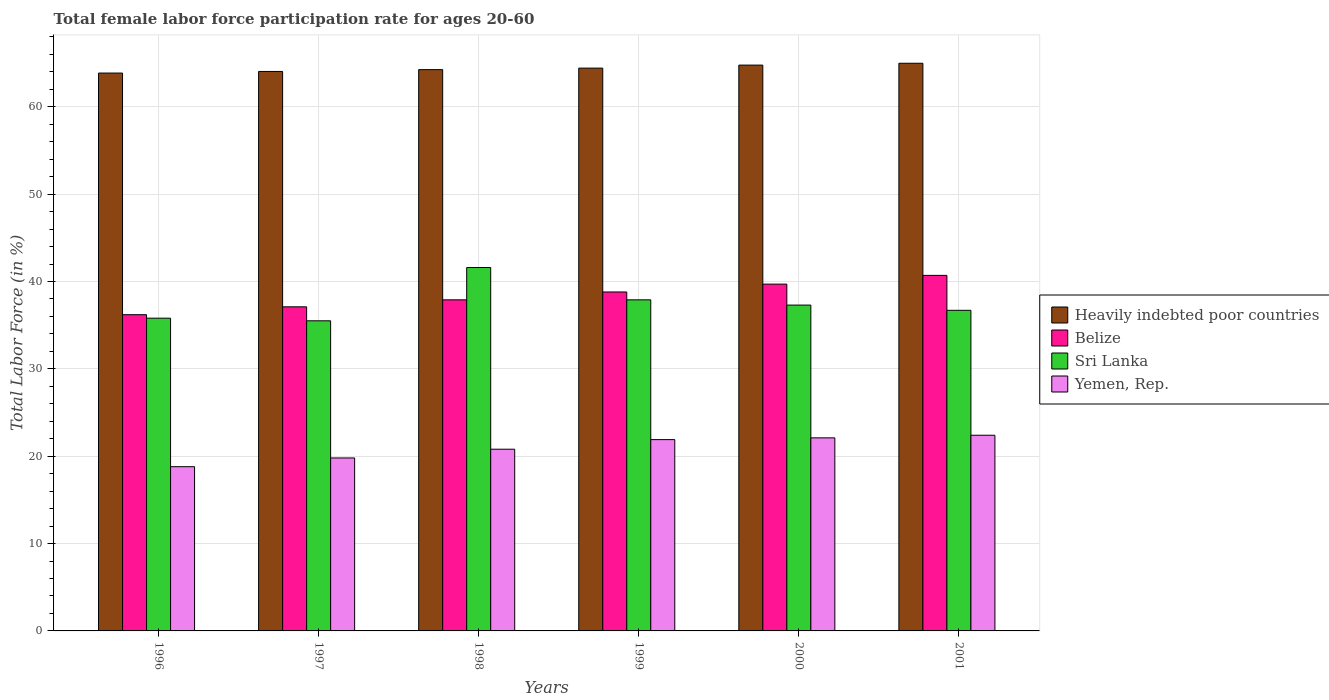How many different coloured bars are there?
Your answer should be very brief. 4. Are the number of bars per tick equal to the number of legend labels?
Your answer should be very brief. Yes. How many bars are there on the 5th tick from the right?
Offer a very short reply. 4. In how many cases, is the number of bars for a given year not equal to the number of legend labels?
Give a very brief answer. 0. What is the female labor force participation rate in Belize in 1999?
Provide a succinct answer. 38.8. Across all years, what is the maximum female labor force participation rate in Heavily indebted poor countries?
Offer a terse response. 64.98. Across all years, what is the minimum female labor force participation rate in Belize?
Your answer should be very brief. 36.2. In which year was the female labor force participation rate in Sri Lanka maximum?
Your answer should be compact. 1998. In which year was the female labor force participation rate in Sri Lanka minimum?
Ensure brevity in your answer.  1997. What is the total female labor force participation rate in Yemen, Rep. in the graph?
Offer a very short reply. 125.8. What is the difference between the female labor force participation rate in Belize in 1999 and that in 2000?
Offer a terse response. -0.9. What is the average female labor force participation rate in Heavily indebted poor countries per year?
Ensure brevity in your answer.  64.39. In the year 2001, what is the difference between the female labor force participation rate in Yemen, Rep. and female labor force participation rate in Sri Lanka?
Give a very brief answer. -14.3. In how many years, is the female labor force participation rate in Heavily indebted poor countries greater than 36 %?
Offer a terse response. 6. What is the ratio of the female labor force participation rate in Sri Lanka in 1997 to that in 1998?
Your answer should be compact. 0.85. Is the difference between the female labor force participation rate in Yemen, Rep. in 1996 and 1998 greater than the difference between the female labor force participation rate in Sri Lanka in 1996 and 1998?
Your response must be concise. Yes. What is the difference between the highest and the second highest female labor force participation rate in Belize?
Give a very brief answer. 1. What is the difference between the highest and the lowest female labor force participation rate in Heavily indebted poor countries?
Make the answer very short. 1.12. Is it the case that in every year, the sum of the female labor force participation rate in Yemen, Rep. and female labor force participation rate in Belize is greater than the sum of female labor force participation rate in Sri Lanka and female labor force participation rate in Heavily indebted poor countries?
Offer a very short reply. No. What does the 1st bar from the left in 2001 represents?
Give a very brief answer. Heavily indebted poor countries. What does the 3rd bar from the right in 1997 represents?
Your answer should be very brief. Belize. Is it the case that in every year, the sum of the female labor force participation rate in Sri Lanka and female labor force participation rate in Yemen, Rep. is greater than the female labor force participation rate in Belize?
Give a very brief answer. Yes. Are all the bars in the graph horizontal?
Provide a short and direct response. No. What is the difference between two consecutive major ticks on the Y-axis?
Ensure brevity in your answer.  10. Are the values on the major ticks of Y-axis written in scientific E-notation?
Make the answer very short. No. Does the graph contain any zero values?
Keep it short and to the point. No. Where does the legend appear in the graph?
Make the answer very short. Center right. How many legend labels are there?
Your answer should be very brief. 4. How are the legend labels stacked?
Offer a very short reply. Vertical. What is the title of the graph?
Give a very brief answer. Total female labor force participation rate for ages 20-60. Does "Guatemala" appear as one of the legend labels in the graph?
Make the answer very short. No. What is the Total Labor Force (in %) of Heavily indebted poor countries in 1996?
Provide a short and direct response. 63.86. What is the Total Labor Force (in %) in Belize in 1996?
Make the answer very short. 36.2. What is the Total Labor Force (in %) of Sri Lanka in 1996?
Ensure brevity in your answer.  35.8. What is the Total Labor Force (in %) of Yemen, Rep. in 1996?
Offer a very short reply. 18.8. What is the Total Labor Force (in %) of Heavily indebted poor countries in 1997?
Your answer should be very brief. 64.04. What is the Total Labor Force (in %) in Belize in 1997?
Ensure brevity in your answer.  37.1. What is the Total Labor Force (in %) in Sri Lanka in 1997?
Ensure brevity in your answer.  35.5. What is the Total Labor Force (in %) in Yemen, Rep. in 1997?
Ensure brevity in your answer.  19.8. What is the Total Labor Force (in %) of Heavily indebted poor countries in 1998?
Ensure brevity in your answer.  64.25. What is the Total Labor Force (in %) of Belize in 1998?
Ensure brevity in your answer.  37.9. What is the Total Labor Force (in %) of Sri Lanka in 1998?
Provide a short and direct response. 41.6. What is the Total Labor Force (in %) of Yemen, Rep. in 1998?
Your response must be concise. 20.8. What is the Total Labor Force (in %) of Heavily indebted poor countries in 1999?
Provide a succinct answer. 64.43. What is the Total Labor Force (in %) in Belize in 1999?
Your answer should be very brief. 38.8. What is the Total Labor Force (in %) of Sri Lanka in 1999?
Provide a succinct answer. 37.9. What is the Total Labor Force (in %) in Yemen, Rep. in 1999?
Keep it short and to the point. 21.9. What is the Total Labor Force (in %) in Heavily indebted poor countries in 2000?
Give a very brief answer. 64.77. What is the Total Labor Force (in %) in Belize in 2000?
Keep it short and to the point. 39.7. What is the Total Labor Force (in %) of Sri Lanka in 2000?
Offer a very short reply. 37.3. What is the Total Labor Force (in %) of Yemen, Rep. in 2000?
Your answer should be compact. 22.1. What is the Total Labor Force (in %) of Heavily indebted poor countries in 2001?
Give a very brief answer. 64.98. What is the Total Labor Force (in %) in Belize in 2001?
Your response must be concise. 40.7. What is the Total Labor Force (in %) of Sri Lanka in 2001?
Keep it short and to the point. 36.7. What is the Total Labor Force (in %) in Yemen, Rep. in 2001?
Keep it short and to the point. 22.4. Across all years, what is the maximum Total Labor Force (in %) in Heavily indebted poor countries?
Provide a succinct answer. 64.98. Across all years, what is the maximum Total Labor Force (in %) of Belize?
Provide a succinct answer. 40.7. Across all years, what is the maximum Total Labor Force (in %) in Sri Lanka?
Give a very brief answer. 41.6. Across all years, what is the maximum Total Labor Force (in %) of Yemen, Rep.?
Make the answer very short. 22.4. Across all years, what is the minimum Total Labor Force (in %) of Heavily indebted poor countries?
Your answer should be very brief. 63.86. Across all years, what is the minimum Total Labor Force (in %) of Belize?
Keep it short and to the point. 36.2. Across all years, what is the minimum Total Labor Force (in %) in Sri Lanka?
Give a very brief answer. 35.5. Across all years, what is the minimum Total Labor Force (in %) in Yemen, Rep.?
Your answer should be compact. 18.8. What is the total Total Labor Force (in %) of Heavily indebted poor countries in the graph?
Keep it short and to the point. 386.34. What is the total Total Labor Force (in %) in Belize in the graph?
Your response must be concise. 230.4. What is the total Total Labor Force (in %) in Sri Lanka in the graph?
Ensure brevity in your answer.  224.8. What is the total Total Labor Force (in %) of Yemen, Rep. in the graph?
Your answer should be very brief. 125.8. What is the difference between the Total Labor Force (in %) in Heavily indebted poor countries in 1996 and that in 1997?
Make the answer very short. -0.18. What is the difference between the Total Labor Force (in %) of Belize in 1996 and that in 1997?
Provide a succinct answer. -0.9. What is the difference between the Total Labor Force (in %) in Heavily indebted poor countries in 1996 and that in 1998?
Give a very brief answer. -0.39. What is the difference between the Total Labor Force (in %) in Sri Lanka in 1996 and that in 1998?
Offer a terse response. -5.8. What is the difference between the Total Labor Force (in %) in Heavily indebted poor countries in 1996 and that in 1999?
Provide a short and direct response. -0.57. What is the difference between the Total Labor Force (in %) in Heavily indebted poor countries in 1996 and that in 2000?
Offer a terse response. -0.91. What is the difference between the Total Labor Force (in %) of Belize in 1996 and that in 2000?
Your answer should be very brief. -3.5. What is the difference between the Total Labor Force (in %) of Sri Lanka in 1996 and that in 2000?
Keep it short and to the point. -1.5. What is the difference between the Total Labor Force (in %) in Yemen, Rep. in 1996 and that in 2000?
Offer a very short reply. -3.3. What is the difference between the Total Labor Force (in %) in Heavily indebted poor countries in 1996 and that in 2001?
Offer a very short reply. -1.12. What is the difference between the Total Labor Force (in %) in Belize in 1996 and that in 2001?
Offer a very short reply. -4.5. What is the difference between the Total Labor Force (in %) of Heavily indebted poor countries in 1997 and that in 1998?
Offer a very short reply. -0.21. What is the difference between the Total Labor Force (in %) of Heavily indebted poor countries in 1997 and that in 1999?
Offer a very short reply. -0.38. What is the difference between the Total Labor Force (in %) of Heavily indebted poor countries in 1997 and that in 2000?
Your response must be concise. -0.73. What is the difference between the Total Labor Force (in %) of Sri Lanka in 1997 and that in 2000?
Provide a short and direct response. -1.8. What is the difference between the Total Labor Force (in %) in Yemen, Rep. in 1997 and that in 2000?
Give a very brief answer. -2.3. What is the difference between the Total Labor Force (in %) in Heavily indebted poor countries in 1997 and that in 2001?
Offer a very short reply. -0.94. What is the difference between the Total Labor Force (in %) of Belize in 1997 and that in 2001?
Your answer should be very brief. -3.6. What is the difference between the Total Labor Force (in %) in Sri Lanka in 1997 and that in 2001?
Your answer should be compact. -1.2. What is the difference between the Total Labor Force (in %) of Heavily indebted poor countries in 1998 and that in 1999?
Your answer should be compact. -0.17. What is the difference between the Total Labor Force (in %) in Yemen, Rep. in 1998 and that in 1999?
Provide a succinct answer. -1.1. What is the difference between the Total Labor Force (in %) in Heavily indebted poor countries in 1998 and that in 2000?
Provide a succinct answer. -0.52. What is the difference between the Total Labor Force (in %) of Sri Lanka in 1998 and that in 2000?
Your answer should be compact. 4.3. What is the difference between the Total Labor Force (in %) in Heavily indebted poor countries in 1998 and that in 2001?
Your answer should be very brief. -0.73. What is the difference between the Total Labor Force (in %) of Sri Lanka in 1998 and that in 2001?
Provide a short and direct response. 4.9. What is the difference between the Total Labor Force (in %) of Heavily indebted poor countries in 1999 and that in 2000?
Give a very brief answer. -0.35. What is the difference between the Total Labor Force (in %) of Belize in 1999 and that in 2000?
Provide a short and direct response. -0.9. What is the difference between the Total Labor Force (in %) in Heavily indebted poor countries in 1999 and that in 2001?
Keep it short and to the point. -0.56. What is the difference between the Total Labor Force (in %) of Sri Lanka in 1999 and that in 2001?
Provide a short and direct response. 1.2. What is the difference between the Total Labor Force (in %) in Yemen, Rep. in 1999 and that in 2001?
Ensure brevity in your answer.  -0.5. What is the difference between the Total Labor Force (in %) of Heavily indebted poor countries in 2000 and that in 2001?
Provide a short and direct response. -0.21. What is the difference between the Total Labor Force (in %) in Sri Lanka in 2000 and that in 2001?
Ensure brevity in your answer.  0.6. What is the difference between the Total Labor Force (in %) of Heavily indebted poor countries in 1996 and the Total Labor Force (in %) of Belize in 1997?
Provide a succinct answer. 26.76. What is the difference between the Total Labor Force (in %) of Heavily indebted poor countries in 1996 and the Total Labor Force (in %) of Sri Lanka in 1997?
Offer a very short reply. 28.36. What is the difference between the Total Labor Force (in %) of Heavily indebted poor countries in 1996 and the Total Labor Force (in %) of Yemen, Rep. in 1997?
Ensure brevity in your answer.  44.06. What is the difference between the Total Labor Force (in %) of Heavily indebted poor countries in 1996 and the Total Labor Force (in %) of Belize in 1998?
Provide a short and direct response. 25.96. What is the difference between the Total Labor Force (in %) of Heavily indebted poor countries in 1996 and the Total Labor Force (in %) of Sri Lanka in 1998?
Give a very brief answer. 22.26. What is the difference between the Total Labor Force (in %) in Heavily indebted poor countries in 1996 and the Total Labor Force (in %) in Yemen, Rep. in 1998?
Offer a very short reply. 43.06. What is the difference between the Total Labor Force (in %) in Belize in 1996 and the Total Labor Force (in %) in Sri Lanka in 1998?
Offer a very short reply. -5.4. What is the difference between the Total Labor Force (in %) of Heavily indebted poor countries in 1996 and the Total Labor Force (in %) of Belize in 1999?
Provide a succinct answer. 25.06. What is the difference between the Total Labor Force (in %) in Heavily indebted poor countries in 1996 and the Total Labor Force (in %) in Sri Lanka in 1999?
Offer a very short reply. 25.96. What is the difference between the Total Labor Force (in %) in Heavily indebted poor countries in 1996 and the Total Labor Force (in %) in Yemen, Rep. in 1999?
Your answer should be very brief. 41.96. What is the difference between the Total Labor Force (in %) of Sri Lanka in 1996 and the Total Labor Force (in %) of Yemen, Rep. in 1999?
Your answer should be compact. 13.9. What is the difference between the Total Labor Force (in %) in Heavily indebted poor countries in 1996 and the Total Labor Force (in %) in Belize in 2000?
Provide a succinct answer. 24.16. What is the difference between the Total Labor Force (in %) of Heavily indebted poor countries in 1996 and the Total Labor Force (in %) of Sri Lanka in 2000?
Make the answer very short. 26.56. What is the difference between the Total Labor Force (in %) of Heavily indebted poor countries in 1996 and the Total Labor Force (in %) of Yemen, Rep. in 2000?
Offer a terse response. 41.76. What is the difference between the Total Labor Force (in %) in Belize in 1996 and the Total Labor Force (in %) in Sri Lanka in 2000?
Ensure brevity in your answer.  -1.1. What is the difference between the Total Labor Force (in %) of Heavily indebted poor countries in 1996 and the Total Labor Force (in %) of Belize in 2001?
Your answer should be compact. 23.16. What is the difference between the Total Labor Force (in %) in Heavily indebted poor countries in 1996 and the Total Labor Force (in %) in Sri Lanka in 2001?
Your response must be concise. 27.16. What is the difference between the Total Labor Force (in %) in Heavily indebted poor countries in 1996 and the Total Labor Force (in %) in Yemen, Rep. in 2001?
Provide a succinct answer. 41.46. What is the difference between the Total Labor Force (in %) of Belize in 1996 and the Total Labor Force (in %) of Yemen, Rep. in 2001?
Offer a very short reply. 13.8. What is the difference between the Total Labor Force (in %) of Heavily indebted poor countries in 1997 and the Total Labor Force (in %) of Belize in 1998?
Your answer should be compact. 26.14. What is the difference between the Total Labor Force (in %) in Heavily indebted poor countries in 1997 and the Total Labor Force (in %) in Sri Lanka in 1998?
Keep it short and to the point. 22.44. What is the difference between the Total Labor Force (in %) of Heavily indebted poor countries in 1997 and the Total Labor Force (in %) of Yemen, Rep. in 1998?
Provide a short and direct response. 43.24. What is the difference between the Total Labor Force (in %) of Belize in 1997 and the Total Labor Force (in %) of Yemen, Rep. in 1998?
Give a very brief answer. 16.3. What is the difference between the Total Labor Force (in %) of Heavily indebted poor countries in 1997 and the Total Labor Force (in %) of Belize in 1999?
Provide a short and direct response. 25.24. What is the difference between the Total Labor Force (in %) in Heavily indebted poor countries in 1997 and the Total Labor Force (in %) in Sri Lanka in 1999?
Your response must be concise. 26.14. What is the difference between the Total Labor Force (in %) of Heavily indebted poor countries in 1997 and the Total Labor Force (in %) of Yemen, Rep. in 1999?
Offer a very short reply. 42.14. What is the difference between the Total Labor Force (in %) of Belize in 1997 and the Total Labor Force (in %) of Sri Lanka in 1999?
Give a very brief answer. -0.8. What is the difference between the Total Labor Force (in %) in Sri Lanka in 1997 and the Total Labor Force (in %) in Yemen, Rep. in 1999?
Keep it short and to the point. 13.6. What is the difference between the Total Labor Force (in %) in Heavily indebted poor countries in 1997 and the Total Labor Force (in %) in Belize in 2000?
Make the answer very short. 24.34. What is the difference between the Total Labor Force (in %) of Heavily indebted poor countries in 1997 and the Total Labor Force (in %) of Sri Lanka in 2000?
Make the answer very short. 26.74. What is the difference between the Total Labor Force (in %) of Heavily indebted poor countries in 1997 and the Total Labor Force (in %) of Yemen, Rep. in 2000?
Your answer should be compact. 41.94. What is the difference between the Total Labor Force (in %) in Belize in 1997 and the Total Labor Force (in %) in Sri Lanka in 2000?
Keep it short and to the point. -0.2. What is the difference between the Total Labor Force (in %) in Belize in 1997 and the Total Labor Force (in %) in Yemen, Rep. in 2000?
Offer a terse response. 15. What is the difference between the Total Labor Force (in %) of Heavily indebted poor countries in 1997 and the Total Labor Force (in %) of Belize in 2001?
Your answer should be compact. 23.34. What is the difference between the Total Labor Force (in %) of Heavily indebted poor countries in 1997 and the Total Labor Force (in %) of Sri Lanka in 2001?
Ensure brevity in your answer.  27.34. What is the difference between the Total Labor Force (in %) of Heavily indebted poor countries in 1997 and the Total Labor Force (in %) of Yemen, Rep. in 2001?
Provide a succinct answer. 41.64. What is the difference between the Total Labor Force (in %) in Belize in 1997 and the Total Labor Force (in %) in Sri Lanka in 2001?
Offer a terse response. 0.4. What is the difference between the Total Labor Force (in %) in Sri Lanka in 1997 and the Total Labor Force (in %) in Yemen, Rep. in 2001?
Offer a very short reply. 13.1. What is the difference between the Total Labor Force (in %) of Heavily indebted poor countries in 1998 and the Total Labor Force (in %) of Belize in 1999?
Your response must be concise. 25.45. What is the difference between the Total Labor Force (in %) in Heavily indebted poor countries in 1998 and the Total Labor Force (in %) in Sri Lanka in 1999?
Offer a very short reply. 26.35. What is the difference between the Total Labor Force (in %) in Heavily indebted poor countries in 1998 and the Total Labor Force (in %) in Yemen, Rep. in 1999?
Provide a short and direct response. 42.35. What is the difference between the Total Labor Force (in %) in Belize in 1998 and the Total Labor Force (in %) in Sri Lanka in 1999?
Your response must be concise. 0. What is the difference between the Total Labor Force (in %) of Sri Lanka in 1998 and the Total Labor Force (in %) of Yemen, Rep. in 1999?
Give a very brief answer. 19.7. What is the difference between the Total Labor Force (in %) in Heavily indebted poor countries in 1998 and the Total Labor Force (in %) in Belize in 2000?
Offer a terse response. 24.55. What is the difference between the Total Labor Force (in %) in Heavily indebted poor countries in 1998 and the Total Labor Force (in %) in Sri Lanka in 2000?
Offer a terse response. 26.95. What is the difference between the Total Labor Force (in %) in Heavily indebted poor countries in 1998 and the Total Labor Force (in %) in Yemen, Rep. in 2000?
Keep it short and to the point. 42.15. What is the difference between the Total Labor Force (in %) of Belize in 1998 and the Total Labor Force (in %) of Yemen, Rep. in 2000?
Give a very brief answer. 15.8. What is the difference between the Total Labor Force (in %) of Heavily indebted poor countries in 1998 and the Total Labor Force (in %) of Belize in 2001?
Your response must be concise. 23.55. What is the difference between the Total Labor Force (in %) in Heavily indebted poor countries in 1998 and the Total Labor Force (in %) in Sri Lanka in 2001?
Ensure brevity in your answer.  27.55. What is the difference between the Total Labor Force (in %) in Heavily indebted poor countries in 1998 and the Total Labor Force (in %) in Yemen, Rep. in 2001?
Offer a very short reply. 41.85. What is the difference between the Total Labor Force (in %) in Belize in 1998 and the Total Labor Force (in %) in Sri Lanka in 2001?
Offer a very short reply. 1.2. What is the difference between the Total Labor Force (in %) in Sri Lanka in 1998 and the Total Labor Force (in %) in Yemen, Rep. in 2001?
Provide a succinct answer. 19.2. What is the difference between the Total Labor Force (in %) of Heavily indebted poor countries in 1999 and the Total Labor Force (in %) of Belize in 2000?
Give a very brief answer. 24.73. What is the difference between the Total Labor Force (in %) of Heavily indebted poor countries in 1999 and the Total Labor Force (in %) of Sri Lanka in 2000?
Offer a very short reply. 27.13. What is the difference between the Total Labor Force (in %) in Heavily indebted poor countries in 1999 and the Total Labor Force (in %) in Yemen, Rep. in 2000?
Offer a very short reply. 42.33. What is the difference between the Total Labor Force (in %) of Belize in 1999 and the Total Labor Force (in %) of Sri Lanka in 2000?
Your answer should be very brief. 1.5. What is the difference between the Total Labor Force (in %) in Heavily indebted poor countries in 1999 and the Total Labor Force (in %) in Belize in 2001?
Your answer should be compact. 23.73. What is the difference between the Total Labor Force (in %) in Heavily indebted poor countries in 1999 and the Total Labor Force (in %) in Sri Lanka in 2001?
Your answer should be compact. 27.73. What is the difference between the Total Labor Force (in %) in Heavily indebted poor countries in 1999 and the Total Labor Force (in %) in Yemen, Rep. in 2001?
Your answer should be compact. 42.03. What is the difference between the Total Labor Force (in %) of Belize in 1999 and the Total Labor Force (in %) of Sri Lanka in 2001?
Your answer should be compact. 2.1. What is the difference between the Total Labor Force (in %) of Belize in 1999 and the Total Labor Force (in %) of Yemen, Rep. in 2001?
Ensure brevity in your answer.  16.4. What is the difference between the Total Labor Force (in %) of Heavily indebted poor countries in 2000 and the Total Labor Force (in %) of Belize in 2001?
Offer a terse response. 24.07. What is the difference between the Total Labor Force (in %) in Heavily indebted poor countries in 2000 and the Total Labor Force (in %) in Sri Lanka in 2001?
Provide a short and direct response. 28.07. What is the difference between the Total Labor Force (in %) in Heavily indebted poor countries in 2000 and the Total Labor Force (in %) in Yemen, Rep. in 2001?
Your answer should be very brief. 42.37. What is the difference between the Total Labor Force (in %) in Sri Lanka in 2000 and the Total Labor Force (in %) in Yemen, Rep. in 2001?
Offer a very short reply. 14.9. What is the average Total Labor Force (in %) of Heavily indebted poor countries per year?
Keep it short and to the point. 64.39. What is the average Total Labor Force (in %) of Belize per year?
Make the answer very short. 38.4. What is the average Total Labor Force (in %) of Sri Lanka per year?
Ensure brevity in your answer.  37.47. What is the average Total Labor Force (in %) in Yemen, Rep. per year?
Offer a very short reply. 20.97. In the year 1996, what is the difference between the Total Labor Force (in %) of Heavily indebted poor countries and Total Labor Force (in %) of Belize?
Ensure brevity in your answer.  27.66. In the year 1996, what is the difference between the Total Labor Force (in %) in Heavily indebted poor countries and Total Labor Force (in %) in Sri Lanka?
Keep it short and to the point. 28.06. In the year 1996, what is the difference between the Total Labor Force (in %) of Heavily indebted poor countries and Total Labor Force (in %) of Yemen, Rep.?
Offer a very short reply. 45.06. In the year 1996, what is the difference between the Total Labor Force (in %) in Belize and Total Labor Force (in %) in Sri Lanka?
Offer a very short reply. 0.4. In the year 1996, what is the difference between the Total Labor Force (in %) in Sri Lanka and Total Labor Force (in %) in Yemen, Rep.?
Keep it short and to the point. 17. In the year 1997, what is the difference between the Total Labor Force (in %) in Heavily indebted poor countries and Total Labor Force (in %) in Belize?
Keep it short and to the point. 26.94. In the year 1997, what is the difference between the Total Labor Force (in %) of Heavily indebted poor countries and Total Labor Force (in %) of Sri Lanka?
Offer a terse response. 28.54. In the year 1997, what is the difference between the Total Labor Force (in %) of Heavily indebted poor countries and Total Labor Force (in %) of Yemen, Rep.?
Give a very brief answer. 44.24. In the year 1997, what is the difference between the Total Labor Force (in %) of Belize and Total Labor Force (in %) of Sri Lanka?
Provide a short and direct response. 1.6. In the year 1997, what is the difference between the Total Labor Force (in %) of Sri Lanka and Total Labor Force (in %) of Yemen, Rep.?
Keep it short and to the point. 15.7. In the year 1998, what is the difference between the Total Labor Force (in %) in Heavily indebted poor countries and Total Labor Force (in %) in Belize?
Make the answer very short. 26.35. In the year 1998, what is the difference between the Total Labor Force (in %) in Heavily indebted poor countries and Total Labor Force (in %) in Sri Lanka?
Ensure brevity in your answer.  22.65. In the year 1998, what is the difference between the Total Labor Force (in %) of Heavily indebted poor countries and Total Labor Force (in %) of Yemen, Rep.?
Keep it short and to the point. 43.45. In the year 1998, what is the difference between the Total Labor Force (in %) of Belize and Total Labor Force (in %) of Yemen, Rep.?
Offer a terse response. 17.1. In the year 1998, what is the difference between the Total Labor Force (in %) of Sri Lanka and Total Labor Force (in %) of Yemen, Rep.?
Give a very brief answer. 20.8. In the year 1999, what is the difference between the Total Labor Force (in %) in Heavily indebted poor countries and Total Labor Force (in %) in Belize?
Provide a short and direct response. 25.63. In the year 1999, what is the difference between the Total Labor Force (in %) of Heavily indebted poor countries and Total Labor Force (in %) of Sri Lanka?
Your response must be concise. 26.53. In the year 1999, what is the difference between the Total Labor Force (in %) of Heavily indebted poor countries and Total Labor Force (in %) of Yemen, Rep.?
Give a very brief answer. 42.53. In the year 2000, what is the difference between the Total Labor Force (in %) in Heavily indebted poor countries and Total Labor Force (in %) in Belize?
Your answer should be very brief. 25.07. In the year 2000, what is the difference between the Total Labor Force (in %) in Heavily indebted poor countries and Total Labor Force (in %) in Sri Lanka?
Ensure brevity in your answer.  27.47. In the year 2000, what is the difference between the Total Labor Force (in %) in Heavily indebted poor countries and Total Labor Force (in %) in Yemen, Rep.?
Make the answer very short. 42.67. In the year 2000, what is the difference between the Total Labor Force (in %) in Sri Lanka and Total Labor Force (in %) in Yemen, Rep.?
Give a very brief answer. 15.2. In the year 2001, what is the difference between the Total Labor Force (in %) in Heavily indebted poor countries and Total Labor Force (in %) in Belize?
Provide a short and direct response. 24.28. In the year 2001, what is the difference between the Total Labor Force (in %) in Heavily indebted poor countries and Total Labor Force (in %) in Sri Lanka?
Make the answer very short. 28.28. In the year 2001, what is the difference between the Total Labor Force (in %) in Heavily indebted poor countries and Total Labor Force (in %) in Yemen, Rep.?
Offer a very short reply. 42.58. In the year 2001, what is the difference between the Total Labor Force (in %) in Belize and Total Labor Force (in %) in Sri Lanka?
Keep it short and to the point. 4. In the year 2001, what is the difference between the Total Labor Force (in %) in Belize and Total Labor Force (in %) in Yemen, Rep.?
Provide a short and direct response. 18.3. What is the ratio of the Total Labor Force (in %) of Heavily indebted poor countries in 1996 to that in 1997?
Your response must be concise. 1. What is the ratio of the Total Labor Force (in %) in Belize in 1996 to that in 1997?
Provide a succinct answer. 0.98. What is the ratio of the Total Labor Force (in %) of Sri Lanka in 1996 to that in 1997?
Make the answer very short. 1.01. What is the ratio of the Total Labor Force (in %) in Yemen, Rep. in 1996 to that in 1997?
Make the answer very short. 0.95. What is the ratio of the Total Labor Force (in %) of Heavily indebted poor countries in 1996 to that in 1998?
Make the answer very short. 0.99. What is the ratio of the Total Labor Force (in %) in Belize in 1996 to that in 1998?
Make the answer very short. 0.96. What is the ratio of the Total Labor Force (in %) of Sri Lanka in 1996 to that in 1998?
Ensure brevity in your answer.  0.86. What is the ratio of the Total Labor Force (in %) of Yemen, Rep. in 1996 to that in 1998?
Your response must be concise. 0.9. What is the ratio of the Total Labor Force (in %) of Heavily indebted poor countries in 1996 to that in 1999?
Offer a very short reply. 0.99. What is the ratio of the Total Labor Force (in %) of Belize in 1996 to that in 1999?
Offer a terse response. 0.93. What is the ratio of the Total Labor Force (in %) of Sri Lanka in 1996 to that in 1999?
Make the answer very short. 0.94. What is the ratio of the Total Labor Force (in %) in Yemen, Rep. in 1996 to that in 1999?
Ensure brevity in your answer.  0.86. What is the ratio of the Total Labor Force (in %) in Heavily indebted poor countries in 1996 to that in 2000?
Give a very brief answer. 0.99. What is the ratio of the Total Labor Force (in %) of Belize in 1996 to that in 2000?
Offer a terse response. 0.91. What is the ratio of the Total Labor Force (in %) in Sri Lanka in 1996 to that in 2000?
Your answer should be compact. 0.96. What is the ratio of the Total Labor Force (in %) in Yemen, Rep. in 1996 to that in 2000?
Keep it short and to the point. 0.85. What is the ratio of the Total Labor Force (in %) of Heavily indebted poor countries in 1996 to that in 2001?
Ensure brevity in your answer.  0.98. What is the ratio of the Total Labor Force (in %) in Belize in 1996 to that in 2001?
Provide a short and direct response. 0.89. What is the ratio of the Total Labor Force (in %) of Sri Lanka in 1996 to that in 2001?
Offer a terse response. 0.98. What is the ratio of the Total Labor Force (in %) in Yemen, Rep. in 1996 to that in 2001?
Give a very brief answer. 0.84. What is the ratio of the Total Labor Force (in %) in Heavily indebted poor countries in 1997 to that in 1998?
Your response must be concise. 1. What is the ratio of the Total Labor Force (in %) of Belize in 1997 to that in 1998?
Provide a succinct answer. 0.98. What is the ratio of the Total Labor Force (in %) of Sri Lanka in 1997 to that in 1998?
Keep it short and to the point. 0.85. What is the ratio of the Total Labor Force (in %) in Yemen, Rep. in 1997 to that in 1998?
Ensure brevity in your answer.  0.95. What is the ratio of the Total Labor Force (in %) in Heavily indebted poor countries in 1997 to that in 1999?
Provide a short and direct response. 0.99. What is the ratio of the Total Labor Force (in %) of Belize in 1997 to that in 1999?
Your answer should be very brief. 0.96. What is the ratio of the Total Labor Force (in %) in Sri Lanka in 1997 to that in 1999?
Ensure brevity in your answer.  0.94. What is the ratio of the Total Labor Force (in %) of Yemen, Rep. in 1997 to that in 1999?
Your response must be concise. 0.9. What is the ratio of the Total Labor Force (in %) of Belize in 1997 to that in 2000?
Your answer should be very brief. 0.93. What is the ratio of the Total Labor Force (in %) in Sri Lanka in 1997 to that in 2000?
Provide a succinct answer. 0.95. What is the ratio of the Total Labor Force (in %) in Yemen, Rep. in 1997 to that in 2000?
Your response must be concise. 0.9. What is the ratio of the Total Labor Force (in %) of Heavily indebted poor countries in 1997 to that in 2001?
Ensure brevity in your answer.  0.99. What is the ratio of the Total Labor Force (in %) in Belize in 1997 to that in 2001?
Give a very brief answer. 0.91. What is the ratio of the Total Labor Force (in %) in Sri Lanka in 1997 to that in 2001?
Offer a very short reply. 0.97. What is the ratio of the Total Labor Force (in %) in Yemen, Rep. in 1997 to that in 2001?
Your answer should be very brief. 0.88. What is the ratio of the Total Labor Force (in %) of Heavily indebted poor countries in 1998 to that in 1999?
Ensure brevity in your answer.  1. What is the ratio of the Total Labor Force (in %) in Belize in 1998 to that in 1999?
Keep it short and to the point. 0.98. What is the ratio of the Total Labor Force (in %) of Sri Lanka in 1998 to that in 1999?
Give a very brief answer. 1.1. What is the ratio of the Total Labor Force (in %) of Yemen, Rep. in 1998 to that in 1999?
Your answer should be very brief. 0.95. What is the ratio of the Total Labor Force (in %) of Heavily indebted poor countries in 1998 to that in 2000?
Your answer should be compact. 0.99. What is the ratio of the Total Labor Force (in %) of Belize in 1998 to that in 2000?
Your answer should be compact. 0.95. What is the ratio of the Total Labor Force (in %) in Sri Lanka in 1998 to that in 2000?
Your response must be concise. 1.12. What is the ratio of the Total Labor Force (in %) in Yemen, Rep. in 1998 to that in 2000?
Offer a terse response. 0.94. What is the ratio of the Total Labor Force (in %) in Heavily indebted poor countries in 1998 to that in 2001?
Give a very brief answer. 0.99. What is the ratio of the Total Labor Force (in %) in Belize in 1998 to that in 2001?
Your answer should be compact. 0.93. What is the ratio of the Total Labor Force (in %) of Sri Lanka in 1998 to that in 2001?
Keep it short and to the point. 1.13. What is the ratio of the Total Labor Force (in %) of Belize in 1999 to that in 2000?
Keep it short and to the point. 0.98. What is the ratio of the Total Labor Force (in %) of Sri Lanka in 1999 to that in 2000?
Your answer should be very brief. 1.02. What is the ratio of the Total Labor Force (in %) in Belize in 1999 to that in 2001?
Your answer should be compact. 0.95. What is the ratio of the Total Labor Force (in %) in Sri Lanka in 1999 to that in 2001?
Give a very brief answer. 1.03. What is the ratio of the Total Labor Force (in %) in Yemen, Rep. in 1999 to that in 2001?
Offer a terse response. 0.98. What is the ratio of the Total Labor Force (in %) in Belize in 2000 to that in 2001?
Provide a short and direct response. 0.98. What is the ratio of the Total Labor Force (in %) of Sri Lanka in 2000 to that in 2001?
Provide a succinct answer. 1.02. What is the ratio of the Total Labor Force (in %) of Yemen, Rep. in 2000 to that in 2001?
Make the answer very short. 0.99. What is the difference between the highest and the second highest Total Labor Force (in %) in Heavily indebted poor countries?
Provide a short and direct response. 0.21. What is the difference between the highest and the second highest Total Labor Force (in %) of Sri Lanka?
Give a very brief answer. 3.7. What is the difference between the highest and the lowest Total Labor Force (in %) of Heavily indebted poor countries?
Provide a short and direct response. 1.12. 